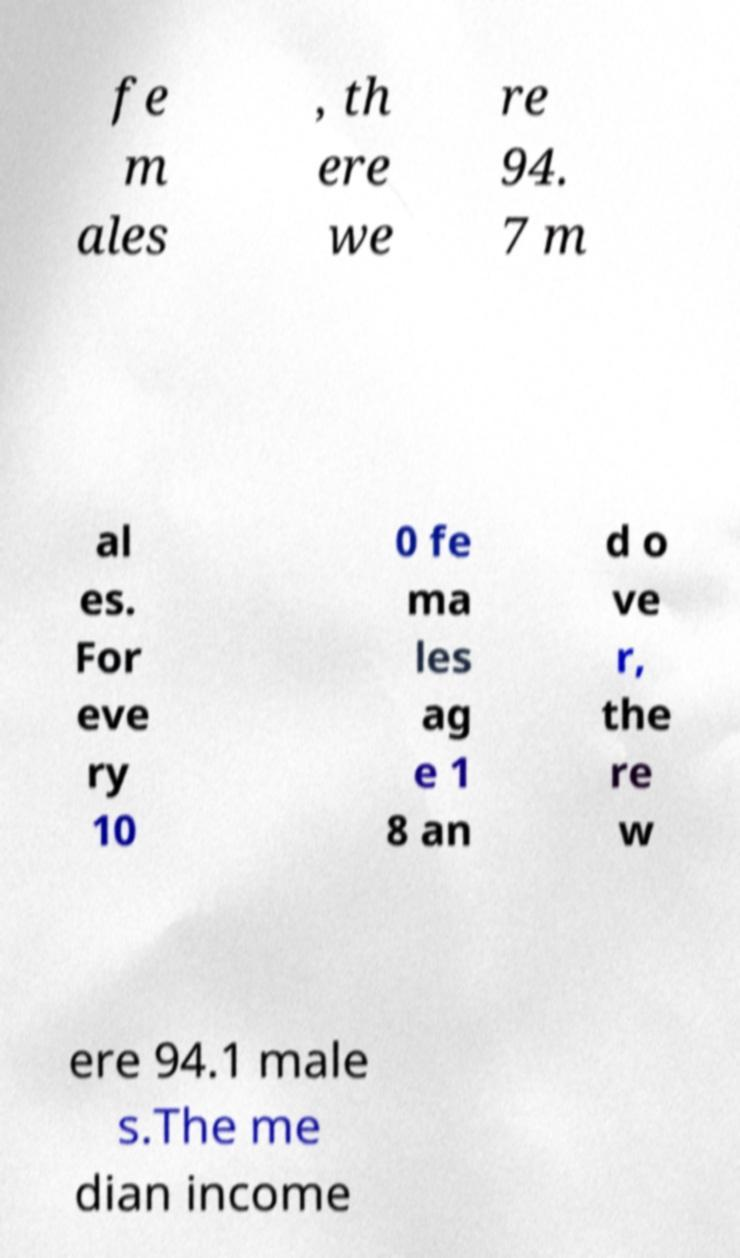Could you extract and type out the text from this image? fe m ales , th ere we re 94. 7 m al es. For eve ry 10 0 fe ma les ag e 1 8 an d o ve r, the re w ere 94.1 male s.The me dian income 